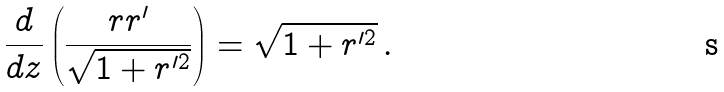<formula> <loc_0><loc_0><loc_500><loc_500>\frac { d } { d z } \left ( \frac { r r ^ { \prime } } { \sqrt { 1 + r ^ { \prime 2 } } } \right ) = \sqrt { 1 + r ^ { \prime 2 } } \, .</formula> 